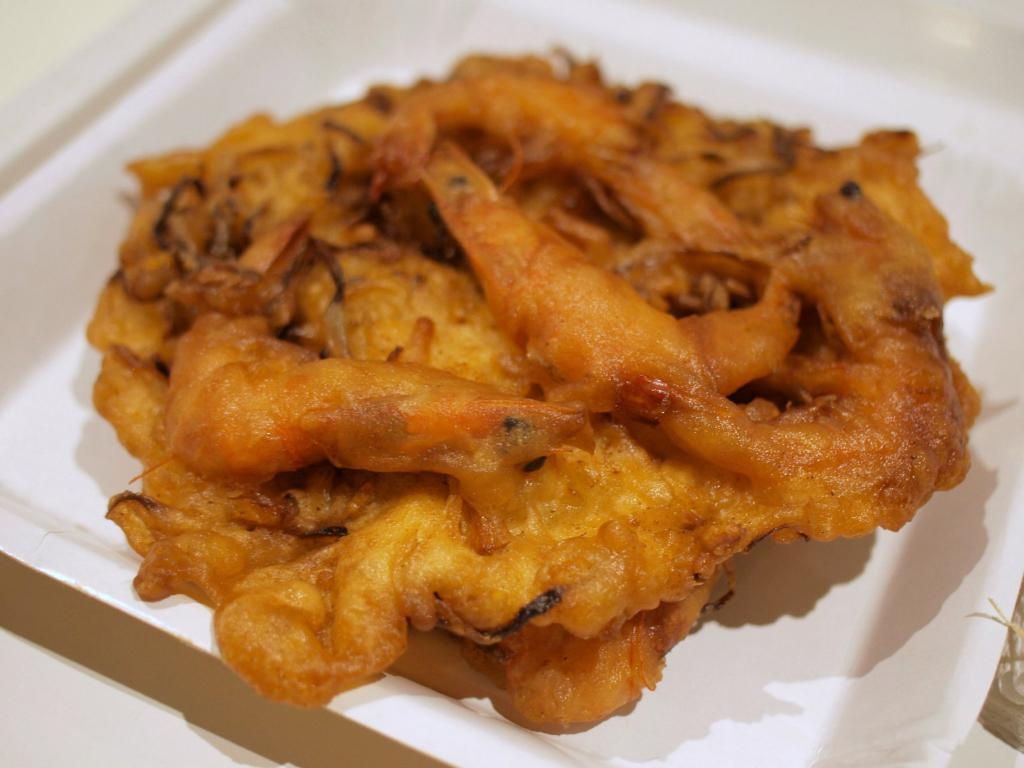What is the main subject of the image? The main subject of the image is a food item on a plate. Can you describe the surface on which the plate is placed? The plate is on a white color surface. What type of fruit is growing on the plate in the image? There is no fruit present on the plate in the image. What scientific theory can be observed in the image? There is no scientific theory depicted in the image; it features a food item on a plate. 